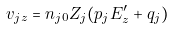<formula> <loc_0><loc_0><loc_500><loc_500>v _ { j z } = n _ { j 0 } Z _ { j } ( p _ { j } E ^ { \prime } _ { z } + q _ { j } )</formula> 